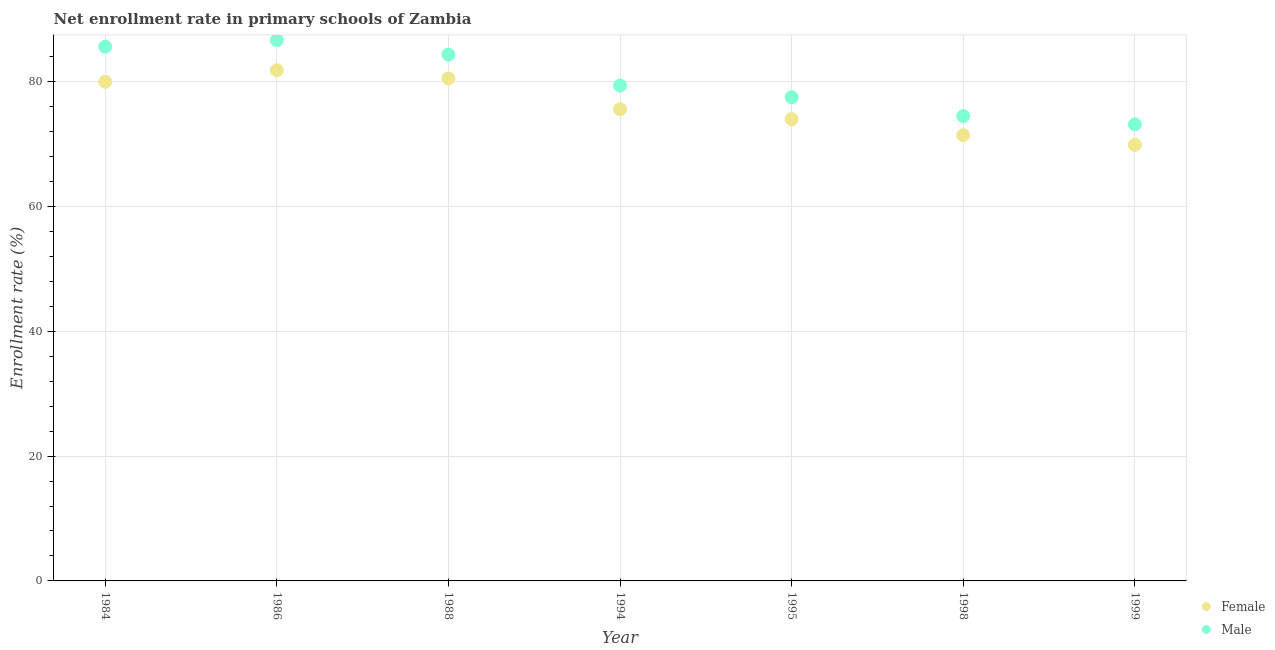What is the enrollment rate of male students in 1998?
Give a very brief answer. 74.46. Across all years, what is the maximum enrollment rate of male students?
Make the answer very short. 86.63. Across all years, what is the minimum enrollment rate of female students?
Give a very brief answer. 69.85. In which year was the enrollment rate of male students maximum?
Your answer should be compact. 1986. What is the total enrollment rate of female students in the graph?
Your answer should be very brief. 533.07. What is the difference between the enrollment rate of male students in 1984 and that in 1988?
Offer a terse response. 1.27. What is the difference between the enrollment rate of female students in 1988 and the enrollment rate of male students in 1984?
Give a very brief answer. -5.09. What is the average enrollment rate of male students per year?
Offer a terse response. 80.14. In the year 1988, what is the difference between the enrollment rate of male students and enrollment rate of female students?
Your answer should be very brief. 3.82. What is the ratio of the enrollment rate of female students in 1986 to that in 1998?
Your answer should be compact. 1.15. Is the enrollment rate of female students in 1986 less than that in 1988?
Your answer should be compact. No. Is the difference between the enrollment rate of male students in 1988 and 1998 greater than the difference between the enrollment rate of female students in 1988 and 1998?
Ensure brevity in your answer.  Yes. What is the difference between the highest and the second highest enrollment rate of female students?
Make the answer very short. 1.32. What is the difference between the highest and the lowest enrollment rate of female students?
Keep it short and to the point. 11.97. Is the sum of the enrollment rate of female students in 1986 and 1999 greater than the maximum enrollment rate of male students across all years?
Provide a short and direct response. Yes. Is the enrollment rate of female students strictly less than the enrollment rate of male students over the years?
Provide a short and direct response. Yes. How many dotlines are there?
Offer a very short reply. 2. What is the difference between two consecutive major ticks on the Y-axis?
Offer a very short reply. 20. Does the graph contain any zero values?
Ensure brevity in your answer.  No. Does the graph contain grids?
Give a very brief answer. Yes. How many legend labels are there?
Offer a terse response. 2. How are the legend labels stacked?
Make the answer very short. Vertical. What is the title of the graph?
Keep it short and to the point. Net enrollment rate in primary schools of Zambia. Does "Official aid received" appear as one of the legend labels in the graph?
Keep it short and to the point. No. What is the label or title of the Y-axis?
Ensure brevity in your answer.  Enrollment rate (%). What is the Enrollment rate (%) in Female in 1984?
Ensure brevity in your answer.  79.97. What is the Enrollment rate (%) in Male in 1984?
Offer a very short reply. 85.58. What is the Enrollment rate (%) of Female in 1986?
Keep it short and to the point. 81.82. What is the Enrollment rate (%) in Male in 1986?
Make the answer very short. 86.63. What is the Enrollment rate (%) in Female in 1988?
Make the answer very short. 80.49. What is the Enrollment rate (%) in Male in 1988?
Offer a terse response. 84.31. What is the Enrollment rate (%) of Female in 1994?
Offer a very short reply. 75.57. What is the Enrollment rate (%) in Male in 1994?
Provide a short and direct response. 79.36. What is the Enrollment rate (%) in Female in 1995?
Give a very brief answer. 73.97. What is the Enrollment rate (%) in Male in 1995?
Offer a terse response. 77.49. What is the Enrollment rate (%) in Female in 1998?
Your answer should be very brief. 71.41. What is the Enrollment rate (%) of Male in 1998?
Your answer should be compact. 74.46. What is the Enrollment rate (%) in Female in 1999?
Your response must be concise. 69.85. What is the Enrollment rate (%) of Male in 1999?
Make the answer very short. 73.14. Across all years, what is the maximum Enrollment rate (%) in Female?
Offer a very short reply. 81.82. Across all years, what is the maximum Enrollment rate (%) in Male?
Make the answer very short. 86.63. Across all years, what is the minimum Enrollment rate (%) of Female?
Make the answer very short. 69.85. Across all years, what is the minimum Enrollment rate (%) of Male?
Offer a very short reply. 73.14. What is the total Enrollment rate (%) of Female in the graph?
Make the answer very short. 533.07. What is the total Enrollment rate (%) in Male in the graph?
Your answer should be very brief. 560.97. What is the difference between the Enrollment rate (%) in Female in 1984 and that in 1986?
Your answer should be very brief. -1.85. What is the difference between the Enrollment rate (%) in Male in 1984 and that in 1986?
Offer a terse response. -1.05. What is the difference between the Enrollment rate (%) in Female in 1984 and that in 1988?
Give a very brief answer. -0.53. What is the difference between the Enrollment rate (%) of Male in 1984 and that in 1988?
Your response must be concise. 1.27. What is the difference between the Enrollment rate (%) of Female in 1984 and that in 1994?
Keep it short and to the point. 4.4. What is the difference between the Enrollment rate (%) in Male in 1984 and that in 1994?
Ensure brevity in your answer.  6.22. What is the difference between the Enrollment rate (%) in Female in 1984 and that in 1995?
Make the answer very short. 5.99. What is the difference between the Enrollment rate (%) in Male in 1984 and that in 1995?
Provide a succinct answer. 8.09. What is the difference between the Enrollment rate (%) of Female in 1984 and that in 1998?
Ensure brevity in your answer.  8.56. What is the difference between the Enrollment rate (%) in Male in 1984 and that in 1998?
Your answer should be very brief. 11.12. What is the difference between the Enrollment rate (%) in Female in 1984 and that in 1999?
Make the answer very short. 10.12. What is the difference between the Enrollment rate (%) of Male in 1984 and that in 1999?
Provide a short and direct response. 12.44. What is the difference between the Enrollment rate (%) in Female in 1986 and that in 1988?
Provide a succinct answer. 1.32. What is the difference between the Enrollment rate (%) in Male in 1986 and that in 1988?
Give a very brief answer. 2.32. What is the difference between the Enrollment rate (%) in Female in 1986 and that in 1994?
Your answer should be very brief. 6.25. What is the difference between the Enrollment rate (%) in Male in 1986 and that in 1994?
Your answer should be compact. 7.28. What is the difference between the Enrollment rate (%) of Female in 1986 and that in 1995?
Your answer should be very brief. 7.84. What is the difference between the Enrollment rate (%) in Male in 1986 and that in 1995?
Ensure brevity in your answer.  9.15. What is the difference between the Enrollment rate (%) in Female in 1986 and that in 1998?
Your answer should be very brief. 10.41. What is the difference between the Enrollment rate (%) of Male in 1986 and that in 1998?
Provide a succinct answer. 12.17. What is the difference between the Enrollment rate (%) in Female in 1986 and that in 1999?
Offer a very short reply. 11.97. What is the difference between the Enrollment rate (%) in Male in 1986 and that in 1999?
Your answer should be compact. 13.5. What is the difference between the Enrollment rate (%) of Female in 1988 and that in 1994?
Offer a very short reply. 4.93. What is the difference between the Enrollment rate (%) of Male in 1988 and that in 1994?
Your answer should be very brief. 4.96. What is the difference between the Enrollment rate (%) of Female in 1988 and that in 1995?
Offer a terse response. 6.52. What is the difference between the Enrollment rate (%) in Male in 1988 and that in 1995?
Give a very brief answer. 6.83. What is the difference between the Enrollment rate (%) in Female in 1988 and that in 1998?
Your answer should be very brief. 9.09. What is the difference between the Enrollment rate (%) in Male in 1988 and that in 1998?
Ensure brevity in your answer.  9.86. What is the difference between the Enrollment rate (%) of Female in 1988 and that in 1999?
Your answer should be very brief. 10.64. What is the difference between the Enrollment rate (%) in Male in 1988 and that in 1999?
Offer a very short reply. 11.18. What is the difference between the Enrollment rate (%) of Female in 1994 and that in 1995?
Ensure brevity in your answer.  1.59. What is the difference between the Enrollment rate (%) of Male in 1994 and that in 1995?
Provide a short and direct response. 1.87. What is the difference between the Enrollment rate (%) of Female in 1994 and that in 1998?
Keep it short and to the point. 4.16. What is the difference between the Enrollment rate (%) of Male in 1994 and that in 1998?
Provide a short and direct response. 4.9. What is the difference between the Enrollment rate (%) of Female in 1994 and that in 1999?
Your answer should be compact. 5.72. What is the difference between the Enrollment rate (%) of Male in 1994 and that in 1999?
Offer a very short reply. 6.22. What is the difference between the Enrollment rate (%) of Female in 1995 and that in 1998?
Provide a short and direct response. 2.57. What is the difference between the Enrollment rate (%) in Male in 1995 and that in 1998?
Your answer should be compact. 3.03. What is the difference between the Enrollment rate (%) in Female in 1995 and that in 1999?
Offer a terse response. 4.12. What is the difference between the Enrollment rate (%) of Male in 1995 and that in 1999?
Your response must be concise. 4.35. What is the difference between the Enrollment rate (%) in Female in 1998 and that in 1999?
Your answer should be compact. 1.55. What is the difference between the Enrollment rate (%) of Male in 1998 and that in 1999?
Offer a very short reply. 1.32. What is the difference between the Enrollment rate (%) in Female in 1984 and the Enrollment rate (%) in Male in 1986?
Offer a terse response. -6.67. What is the difference between the Enrollment rate (%) of Female in 1984 and the Enrollment rate (%) of Male in 1988?
Provide a succinct answer. -4.35. What is the difference between the Enrollment rate (%) in Female in 1984 and the Enrollment rate (%) in Male in 1994?
Your answer should be very brief. 0.61. What is the difference between the Enrollment rate (%) of Female in 1984 and the Enrollment rate (%) of Male in 1995?
Offer a very short reply. 2.48. What is the difference between the Enrollment rate (%) of Female in 1984 and the Enrollment rate (%) of Male in 1998?
Your response must be concise. 5.51. What is the difference between the Enrollment rate (%) in Female in 1984 and the Enrollment rate (%) in Male in 1999?
Your answer should be very brief. 6.83. What is the difference between the Enrollment rate (%) of Female in 1986 and the Enrollment rate (%) of Male in 1988?
Offer a very short reply. -2.5. What is the difference between the Enrollment rate (%) in Female in 1986 and the Enrollment rate (%) in Male in 1994?
Make the answer very short. 2.46. What is the difference between the Enrollment rate (%) in Female in 1986 and the Enrollment rate (%) in Male in 1995?
Keep it short and to the point. 4.33. What is the difference between the Enrollment rate (%) of Female in 1986 and the Enrollment rate (%) of Male in 1998?
Give a very brief answer. 7.36. What is the difference between the Enrollment rate (%) in Female in 1986 and the Enrollment rate (%) in Male in 1999?
Your response must be concise. 8.68. What is the difference between the Enrollment rate (%) of Female in 1988 and the Enrollment rate (%) of Male in 1994?
Offer a very short reply. 1.14. What is the difference between the Enrollment rate (%) in Female in 1988 and the Enrollment rate (%) in Male in 1995?
Provide a succinct answer. 3.01. What is the difference between the Enrollment rate (%) in Female in 1988 and the Enrollment rate (%) in Male in 1998?
Offer a very short reply. 6.03. What is the difference between the Enrollment rate (%) of Female in 1988 and the Enrollment rate (%) of Male in 1999?
Offer a very short reply. 7.36. What is the difference between the Enrollment rate (%) of Female in 1994 and the Enrollment rate (%) of Male in 1995?
Make the answer very short. -1.92. What is the difference between the Enrollment rate (%) in Female in 1994 and the Enrollment rate (%) in Male in 1998?
Your answer should be very brief. 1.11. What is the difference between the Enrollment rate (%) of Female in 1994 and the Enrollment rate (%) of Male in 1999?
Keep it short and to the point. 2.43. What is the difference between the Enrollment rate (%) of Female in 1995 and the Enrollment rate (%) of Male in 1998?
Your answer should be very brief. -0.49. What is the difference between the Enrollment rate (%) in Female in 1995 and the Enrollment rate (%) in Male in 1999?
Your answer should be very brief. 0.84. What is the difference between the Enrollment rate (%) in Female in 1998 and the Enrollment rate (%) in Male in 1999?
Provide a short and direct response. -1.73. What is the average Enrollment rate (%) in Female per year?
Your response must be concise. 76.15. What is the average Enrollment rate (%) of Male per year?
Ensure brevity in your answer.  80.14. In the year 1984, what is the difference between the Enrollment rate (%) in Female and Enrollment rate (%) in Male?
Provide a short and direct response. -5.61. In the year 1986, what is the difference between the Enrollment rate (%) of Female and Enrollment rate (%) of Male?
Give a very brief answer. -4.82. In the year 1988, what is the difference between the Enrollment rate (%) of Female and Enrollment rate (%) of Male?
Your answer should be compact. -3.82. In the year 1994, what is the difference between the Enrollment rate (%) of Female and Enrollment rate (%) of Male?
Make the answer very short. -3.79. In the year 1995, what is the difference between the Enrollment rate (%) in Female and Enrollment rate (%) in Male?
Your answer should be compact. -3.51. In the year 1998, what is the difference between the Enrollment rate (%) in Female and Enrollment rate (%) in Male?
Give a very brief answer. -3.05. In the year 1999, what is the difference between the Enrollment rate (%) of Female and Enrollment rate (%) of Male?
Offer a terse response. -3.29. What is the ratio of the Enrollment rate (%) of Female in 1984 to that in 1986?
Your answer should be compact. 0.98. What is the ratio of the Enrollment rate (%) of Male in 1984 to that in 1988?
Your answer should be very brief. 1.01. What is the ratio of the Enrollment rate (%) in Female in 1984 to that in 1994?
Offer a very short reply. 1.06. What is the ratio of the Enrollment rate (%) in Male in 1984 to that in 1994?
Provide a short and direct response. 1.08. What is the ratio of the Enrollment rate (%) in Female in 1984 to that in 1995?
Ensure brevity in your answer.  1.08. What is the ratio of the Enrollment rate (%) of Male in 1984 to that in 1995?
Offer a very short reply. 1.1. What is the ratio of the Enrollment rate (%) of Female in 1984 to that in 1998?
Make the answer very short. 1.12. What is the ratio of the Enrollment rate (%) of Male in 1984 to that in 1998?
Your response must be concise. 1.15. What is the ratio of the Enrollment rate (%) in Female in 1984 to that in 1999?
Your answer should be very brief. 1.14. What is the ratio of the Enrollment rate (%) of Male in 1984 to that in 1999?
Your answer should be very brief. 1.17. What is the ratio of the Enrollment rate (%) in Female in 1986 to that in 1988?
Your answer should be very brief. 1.02. What is the ratio of the Enrollment rate (%) in Male in 1986 to that in 1988?
Provide a short and direct response. 1.03. What is the ratio of the Enrollment rate (%) in Female in 1986 to that in 1994?
Provide a succinct answer. 1.08. What is the ratio of the Enrollment rate (%) in Male in 1986 to that in 1994?
Give a very brief answer. 1.09. What is the ratio of the Enrollment rate (%) in Female in 1986 to that in 1995?
Keep it short and to the point. 1.11. What is the ratio of the Enrollment rate (%) of Male in 1986 to that in 1995?
Provide a succinct answer. 1.12. What is the ratio of the Enrollment rate (%) in Female in 1986 to that in 1998?
Your answer should be very brief. 1.15. What is the ratio of the Enrollment rate (%) of Male in 1986 to that in 1998?
Your answer should be compact. 1.16. What is the ratio of the Enrollment rate (%) in Female in 1986 to that in 1999?
Offer a terse response. 1.17. What is the ratio of the Enrollment rate (%) in Male in 1986 to that in 1999?
Provide a short and direct response. 1.18. What is the ratio of the Enrollment rate (%) in Female in 1988 to that in 1994?
Offer a very short reply. 1.07. What is the ratio of the Enrollment rate (%) of Male in 1988 to that in 1994?
Ensure brevity in your answer.  1.06. What is the ratio of the Enrollment rate (%) in Female in 1988 to that in 1995?
Provide a short and direct response. 1.09. What is the ratio of the Enrollment rate (%) of Male in 1988 to that in 1995?
Your answer should be compact. 1.09. What is the ratio of the Enrollment rate (%) of Female in 1988 to that in 1998?
Your answer should be compact. 1.13. What is the ratio of the Enrollment rate (%) in Male in 1988 to that in 1998?
Ensure brevity in your answer.  1.13. What is the ratio of the Enrollment rate (%) in Female in 1988 to that in 1999?
Keep it short and to the point. 1.15. What is the ratio of the Enrollment rate (%) of Male in 1988 to that in 1999?
Make the answer very short. 1.15. What is the ratio of the Enrollment rate (%) of Female in 1994 to that in 1995?
Your response must be concise. 1.02. What is the ratio of the Enrollment rate (%) of Male in 1994 to that in 1995?
Offer a very short reply. 1.02. What is the ratio of the Enrollment rate (%) in Female in 1994 to that in 1998?
Your response must be concise. 1.06. What is the ratio of the Enrollment rate (%) of Male in 1994 to that in 1998?
Make the answer very short. 1.07. What is the ratio of the Enrollment rate (%) in Female in 1994 to that in 1999?
Provide a short and direct response. 1.08. What is the ratio of the Enrollment rate (%) of Male in 1994 to that in 1999?
Offer a terse response. 1.09. What is the ratio of the Enrollment rate (%) in Female in 1995 to that in 1998?
Offer a terse response. 1.04. What is the ratio of the Enrollment rate (%) of Male in 1995 to that in 1998?
Give a very brief answer. 1.04. What is the ratio of the Enrollment rate (%) in Female in 1995 to that in 1999?
Give a very brief answer. 1.06. What is the ratio of the Enrollment rate (%) of Male in 1995 to that in 1999?
Keep it short and to the point. 1.06. What is the ratio of the Enrollment rate (%) in Female in 1998 to that in 1999?
Provide a short and direct response. 1.02. What is the ratio of the Enrollment rate (%) in Male in 1998 to that in 1999?
Make the answer very short. 1.02. What is the difference between the highest and the second highest Enrollment rate (%) of Female?
Give a very brief answer. 1.32. What is the difference between the highest and the second highest Enrollment rate (%) of Male?
Your answer should be very brief. 1.05. What is the difference between the highest and the lowest Enrollment rate (%) of Female?
Your answer should be very brief. 11.97. What is the difference between the highest and the lowest Enrollment rate (%) in Male?
Offer a very short reply. 13.5. 